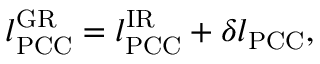Convert formula to latex. <formula><loc_0><loc_0><loc_500><loc_500>\begin{array} { r } { l _ { P C C } ^ { G R } = l _ { P C C } ^ { I R } + \delta l _ { P C C } , } \end{array}</formula> 